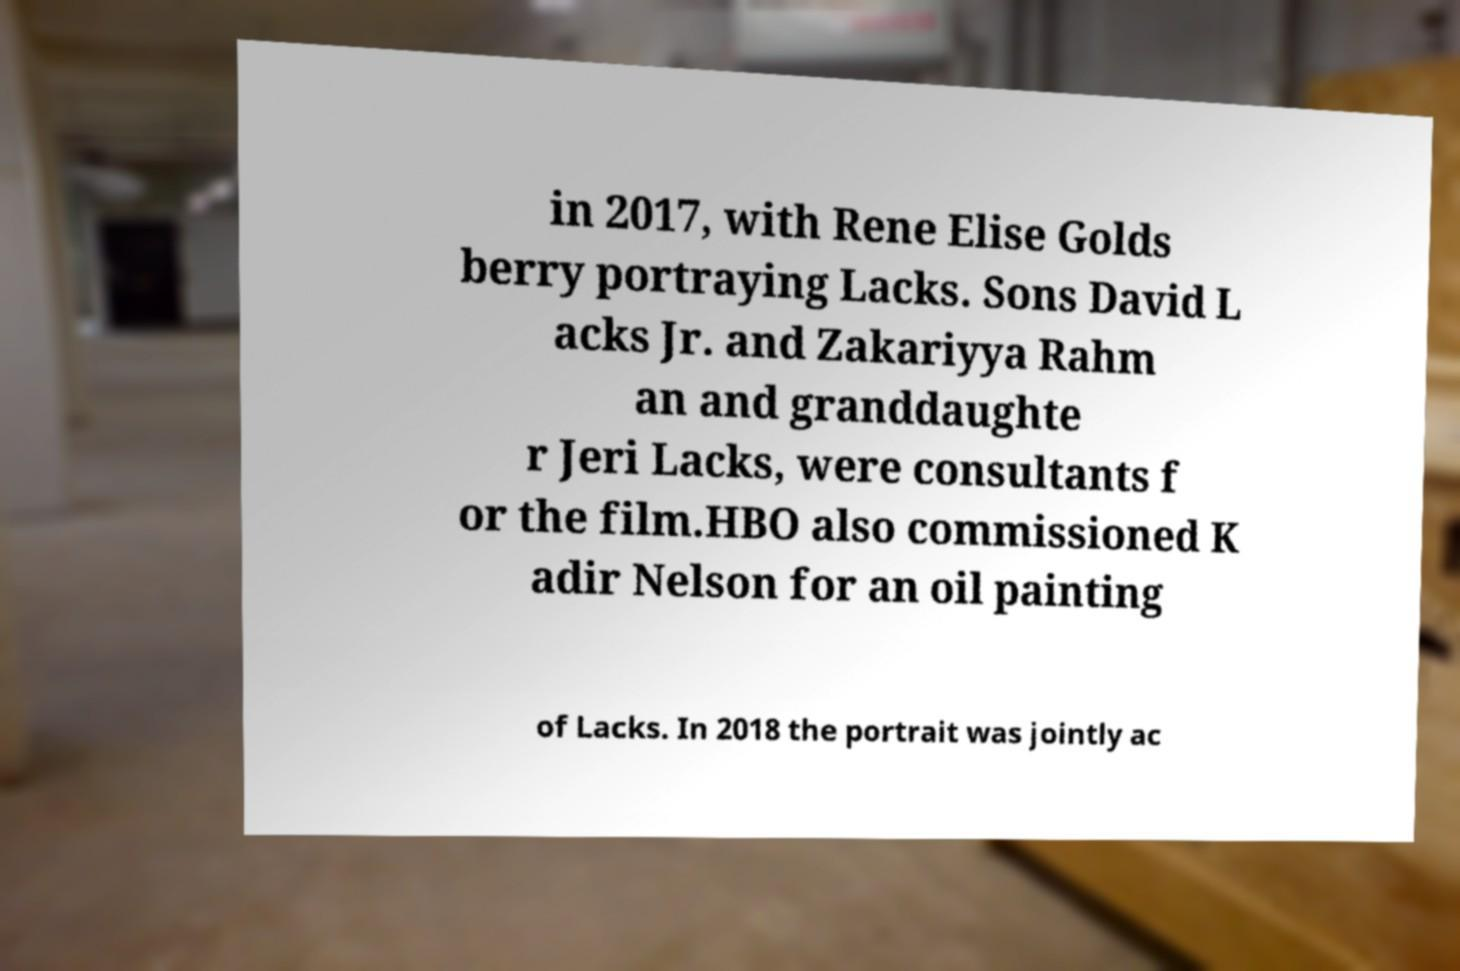Please read and relay the text visible in this image. What does it say? in 2017, with Rene Elise Golds berry portraying Lacks. Sons David L acks Jr. and Zakariyya Rahm an and granddaughte r Jeri Lacks, were consultants f or the film.HBO also commissioned K adir Nelson for an oil painting of Lacks. In 2018 the portrait was jointly ac 